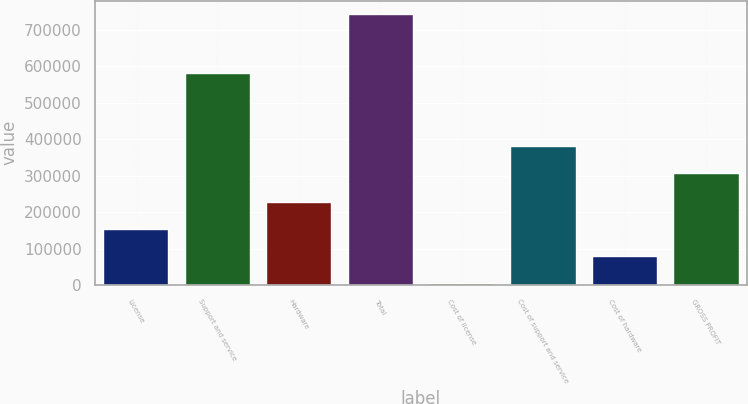<chart> <loc_0><loc_0><loc_500><loc_500><bar_chart><fcel>License<fcel>Support and service<fcel>Hardware<fcel>Total<fcel>Cost of license<fcel>Cost of support and service<fcel>Cost of hardware<fcel>GROSS PROFIT<nl><fcel>153944<fcel>580334<fcel>227566<fcel>742926<fcel>6698<fcel>380849<fcel>80320.8<fcel>307226<nl></chart> 